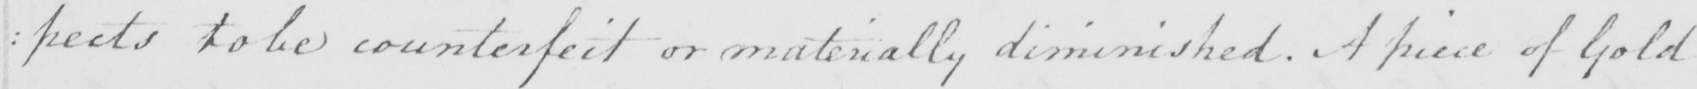Please transcribe the handwritten text in this image. : pects to be counterfeit or materially diminished . A piece of Gold 